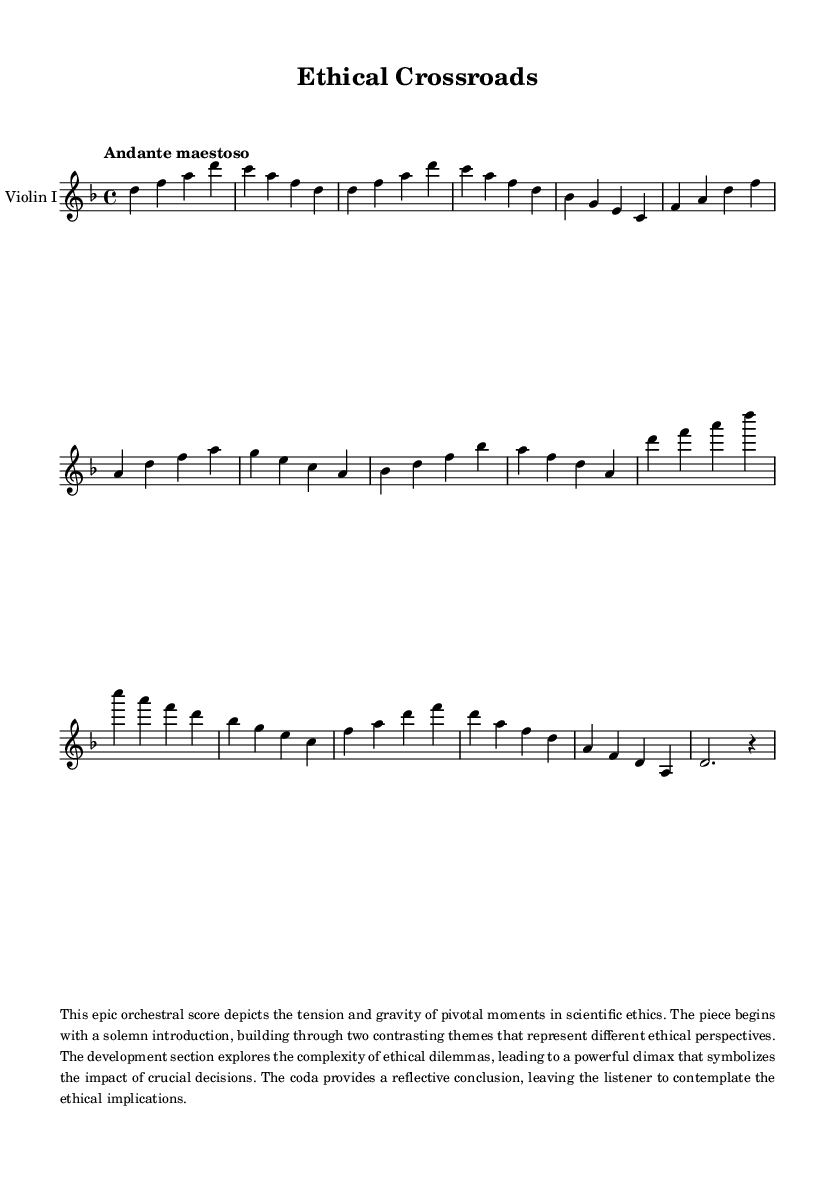What is the key signature of this music? The key signature indicates the piece is in D minor, which includes one flat (B flat).
Answer: D minor What is the time signature of the piece? The time signature is indicated at the beginning of the score as 4/4, meaning there are four beats in a measure and the quarter note gets one beat.
Answer: 4/4 What is the tempo marking of the score? The tempo marking is found at the beginning, stating "Andante maestoso," which indicates a moderately slow and majestic pace.
Answer: Andante maestoso How many main themes are present in the score? The score features two main contrasting themes, labeled as Theme A and Theme B in the description.
Answer: Two What does the climax of the piece represent? The climax is described in the provided context as symbolizing the impact of crucial decisions in the context of scientific ethics, showcasing tension and gravity.
Answer: Impact of crucial decisions Which instrument is specified in the score? The score explicitly mentions "Violin I," indicating that it is specifically written for the first violin.
Answer: Violin I What is the concluding section of the piece called? The final part of the score is referred to as the "Coda," which in music indicates a concluding passage that wraps up the themes presented.
Answer: Coda 